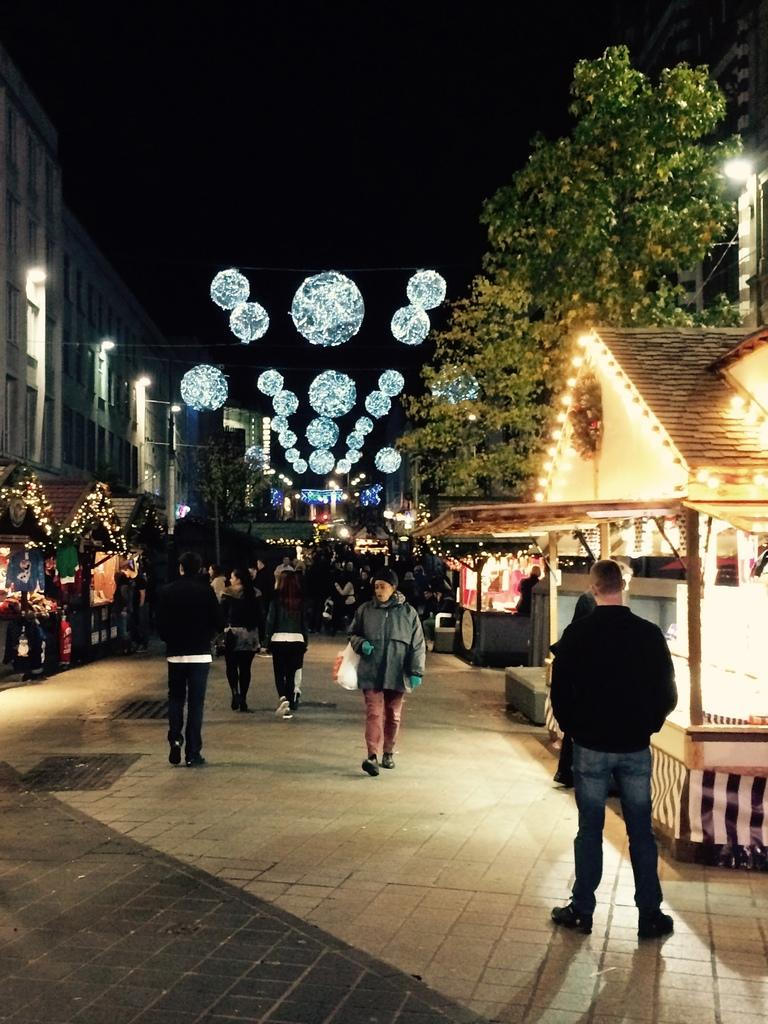What are the people in the image doing? The people in the image are walking on the road. What can be seen in the background of the image? There are buildings, lights, trees, and the sky visible in the background of the image. Can you describe the unspecified objects in the background of the image? Unfortunately, the provided facts do not specify the nature of the unspecified objects in the background. What type of bubble is floating near the people in the image? There is no bubble present in the image. What is the source of power for the engine visible in the image? There is no engine present in the image. 